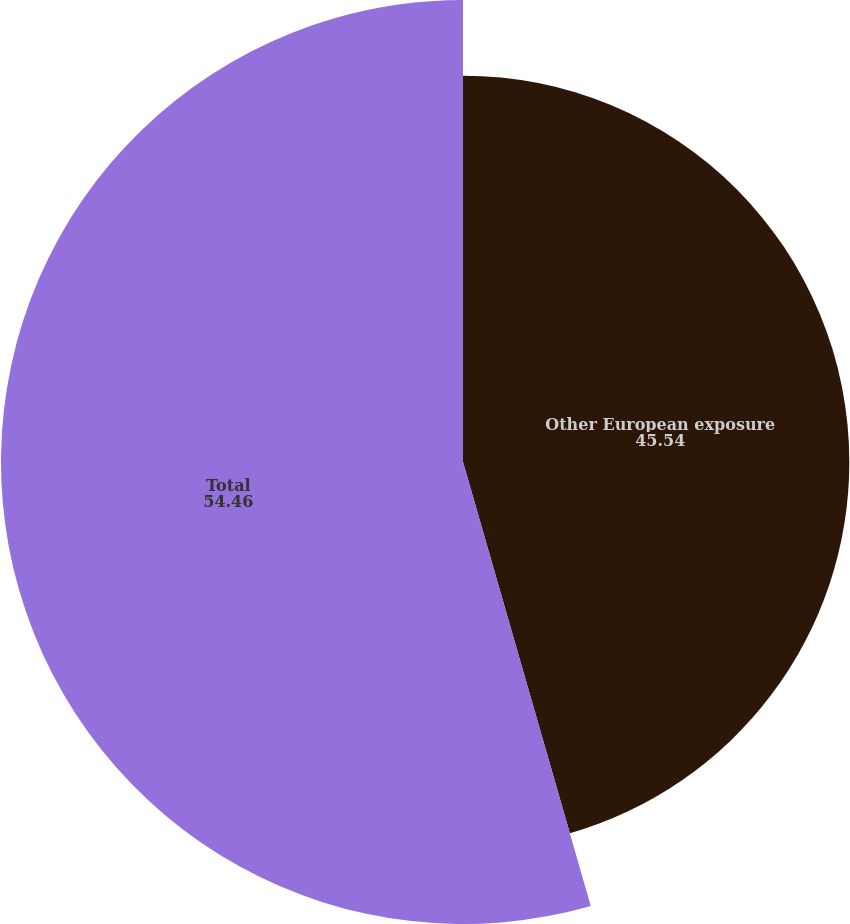Convert chart to OTSL. <chart><loc_0><loc_0><loc_500><loc_500><pie_chart><fcel>Other European exposure<fcel>Total<nl><fcel>45.54%<fcel>54.46%<nl></chart> 